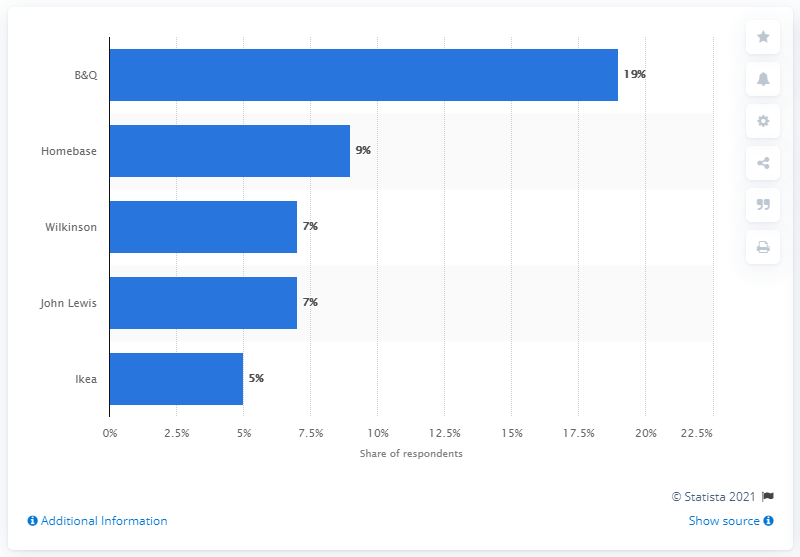List a handful of essential elements in this visual. B&Q's second-highest-ranked retail store was Homebase. 